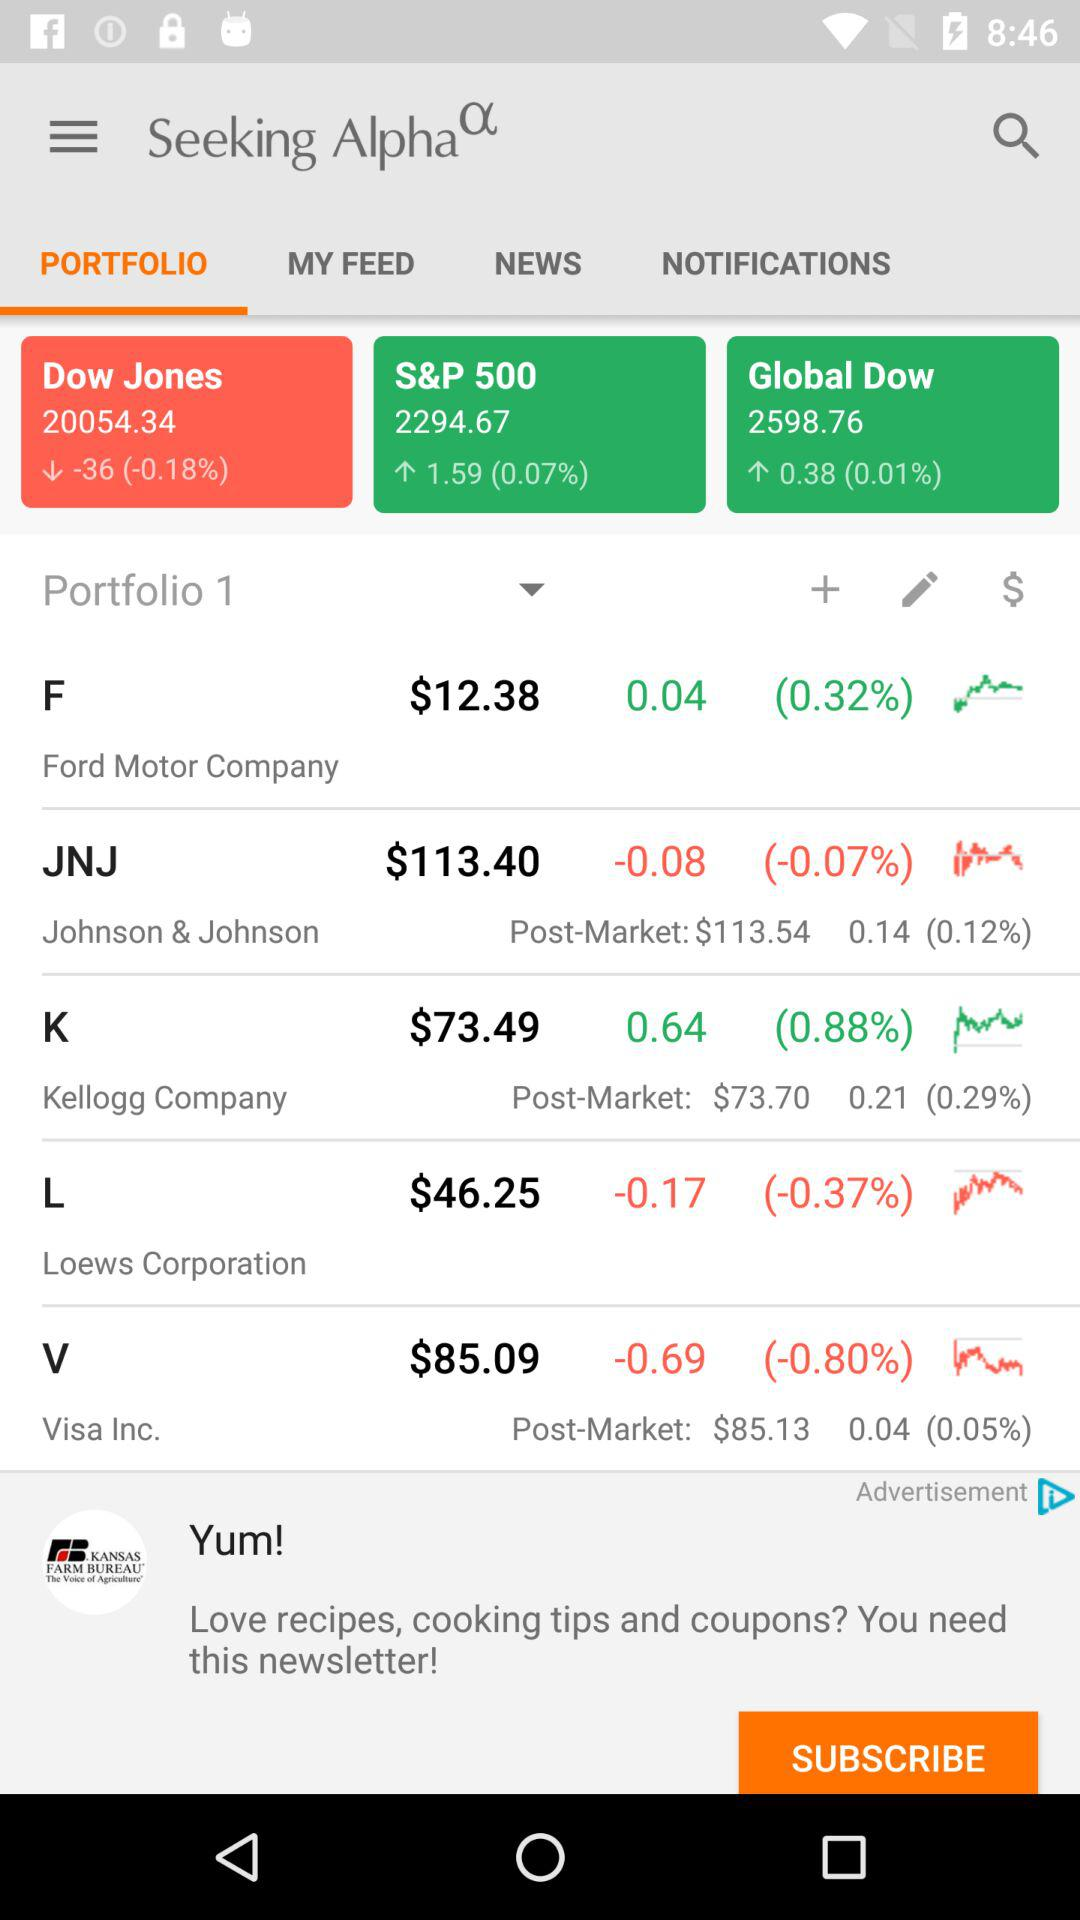How much has the price of Visa Inc. changed since the last market close?
Answer the question using a single word or phrase. -0.69 